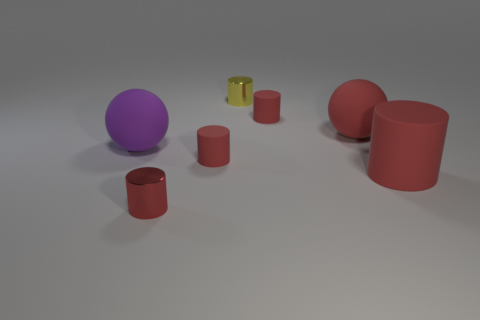How is the lighting affecting the appearance of the objects? The lighting in the image creates soft shadows and highlights the objects' matte textures. It also emphasizes the depth and dimension of the scene, making the colors appear more vibrant. Can you describe the texture of the surfaces in the image? Most objects in the image appear to have a matte texture, which diffuses light and gives a soft, non-reflective finish. This texture is consistent among the cylinders and the sphere, contributing to a cohesive visual aesthetic. 